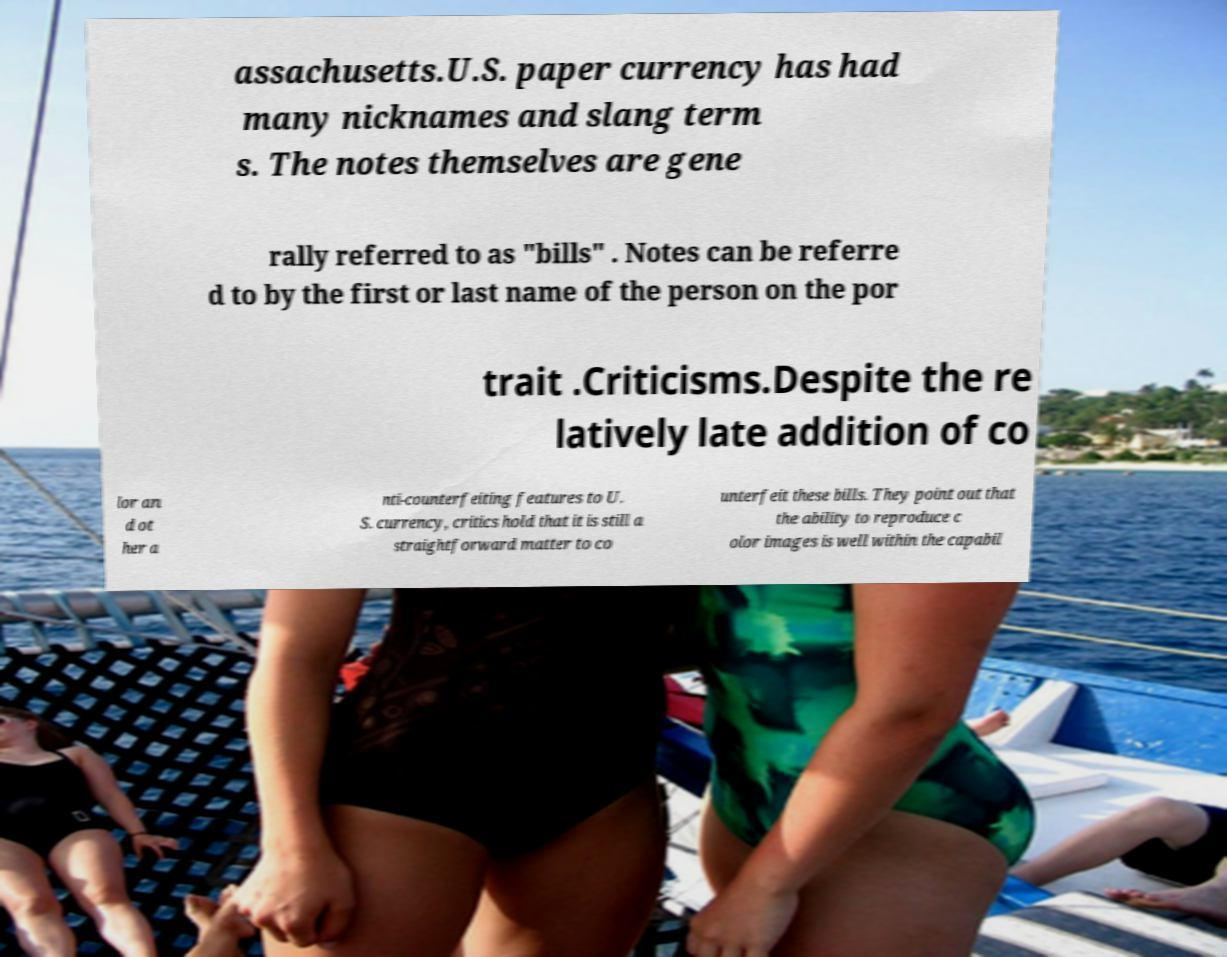For documentation purposes, I need the text within this image transcribed. Could you provide that? assachusetts.U.S. paper currency has had many nicknames and slang term s. The notes themselves are gene rally referred to as "bills" . Notes can be referre d to by the first or last name of the person on the por trait .Criticisms.Despite the re latively late addition of co lor an d ot her a nti-counterfeiting features to U. S. currency, critics hold that it is still a straightforward matter to co unterfeit these bills. They point out that the ability to reproduce c olor images is well within the capabil 